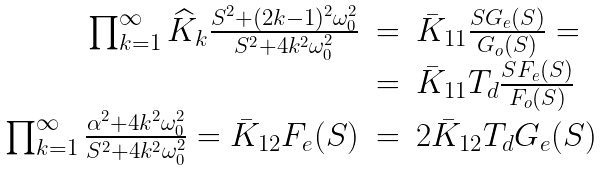<formula> <loc_0><loc_0><loc_500><loc_500>\begin{array} { r c l } \prod _ { k = 1 } ^ { \infty } \widehat { K } _ { k } \frac { S ^ { 2 } + ( 2 k - 1 ) ^ { 2 } \omega _ { 0 } ^ { 2 } } { S ^ { 2 } + 4 k ^ { 2 } \omega _ { 0 } ^ { 2 } } & = & \bar { K } _ { 1 1 } \frac { S G _ { e } ( S ) } { G _ { o } ( S ) } = \\ & = & \bar { K } _ { 1 1 } T _ { d } \frac { S F _ { e } ( S ) } { F _ { o } ( S ) } \\ \prod _ { k = 1 } ^ { \infty } \frac { \alpha ^ { 2 } + 4 k ^ { 2 } \omega _ { 0 } ^ { 2 } } { S ^ { 2 } + 4 k ^ { 2 } \omega _ { 0 } ^ { 2 } } = \bar { K } _ { 1 2 } F _ { e } ( S ) & = & 2 \bar { K } _ { 1 2 } T _ { d } G _ { e } ( S ) \end{array}</formula> 